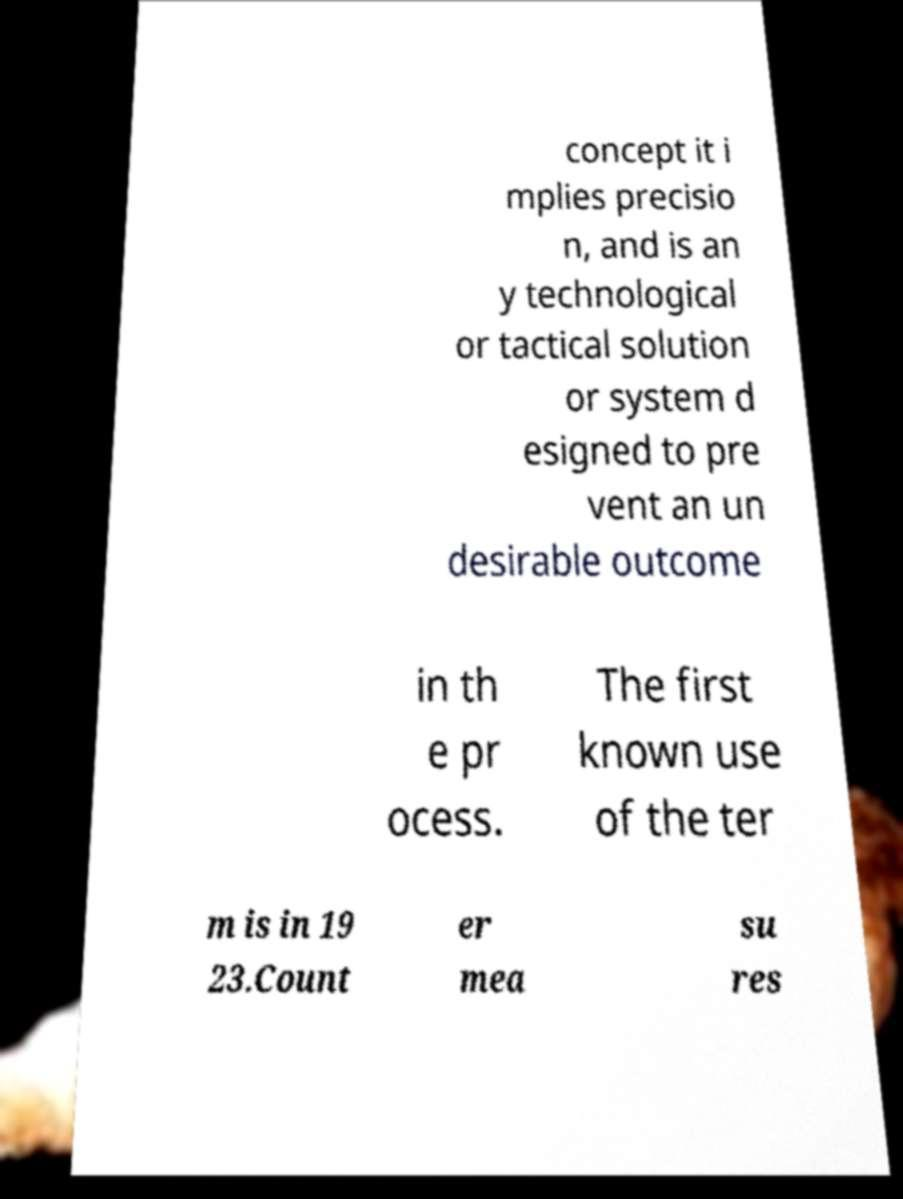Could you assist in decoding the text presented in this image and type it out clearly? concept it i mplies precisio n, and is an y technological or tactical solution or system d esigned to pre vent an un desirable outcome in th e pr ocess. The first known use of the ter m is in 19 23.Count er mea su res 